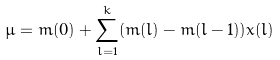<formula> <loc_0><loc_0><loc_500><loc_500>\mu = m ( 0 ) + \sum _ { l = 1 } ^ { k } ( m ( l ) - m ( l - 1 ) ) x ( l )</formula> 